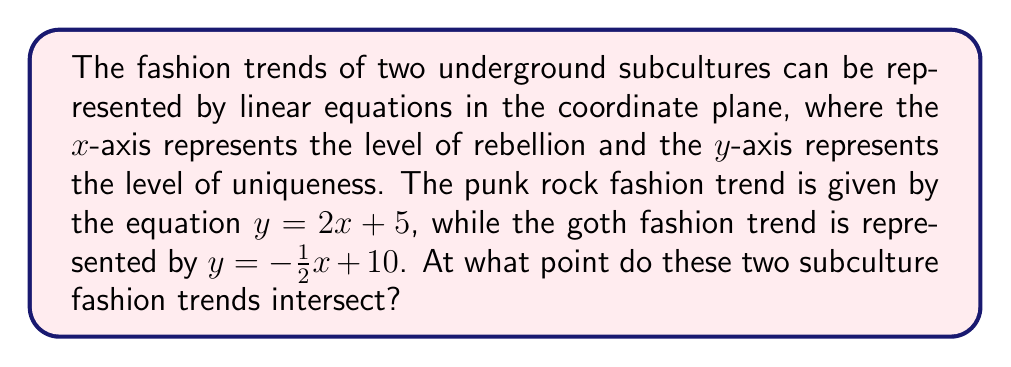Provide a solution to this math problem. To find the intersection point of these two lines, we need to solve the system of equations:

$$\begin{cases}
y = 2x + 5 \\
y = -\frac{1}{2}x + 10
\end{cases}$$

Since both equations are equal to y, we can set them equal to each other:

$$2x + 5 = -\frac{1}{2}x + 10$$

Now, let's solve for x:

1) Add $\frac{1}{2}x$ to both sides:
   $$2x + \frac{1}{2}x + 5 = 10$$
   $$\frac{5}{2}x + 5 = 10$$

2) Subtract 5 from both sides:
   $$\frac{5}{2}x = 5$$

3) Multiply both sides by $\frac{2}{5}$:
   $$x = 2$$

Now that we have x, we can substitute it into either of the original equations to find y. Let's use the punk rock equation:

$$y = 2(2) + 5 = 4 + 5 = 9$$

Therefore, the intersection point is (2, 9).

To visualize this:

[asy]
import graph;
size(200);
xaxis("Level of Rebellion", -1, 6, arrow=Arrow);
yaxis("Level of Uniqueness", -1, 12, arrow=Arrow);

real f(real x) {return 2x + 5;}
real g(real x) {return -0.5x + 10;}

draw(graph(f, -1, 5), blue, "Punk Rock");
draw(graph(g, -1, 5), red, "Goth");

dot((2,9), green);
label("(2, 9)", (2,9), NE);
[/asy]
Answer: The punk rock and goth fashion trends intersect at the point (2, 9). 